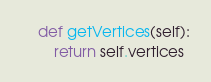<code> <loc_0><loc_0><loc_500><loc_500><_Python_>    def getVertices(self):
        return self.vertices</code> 